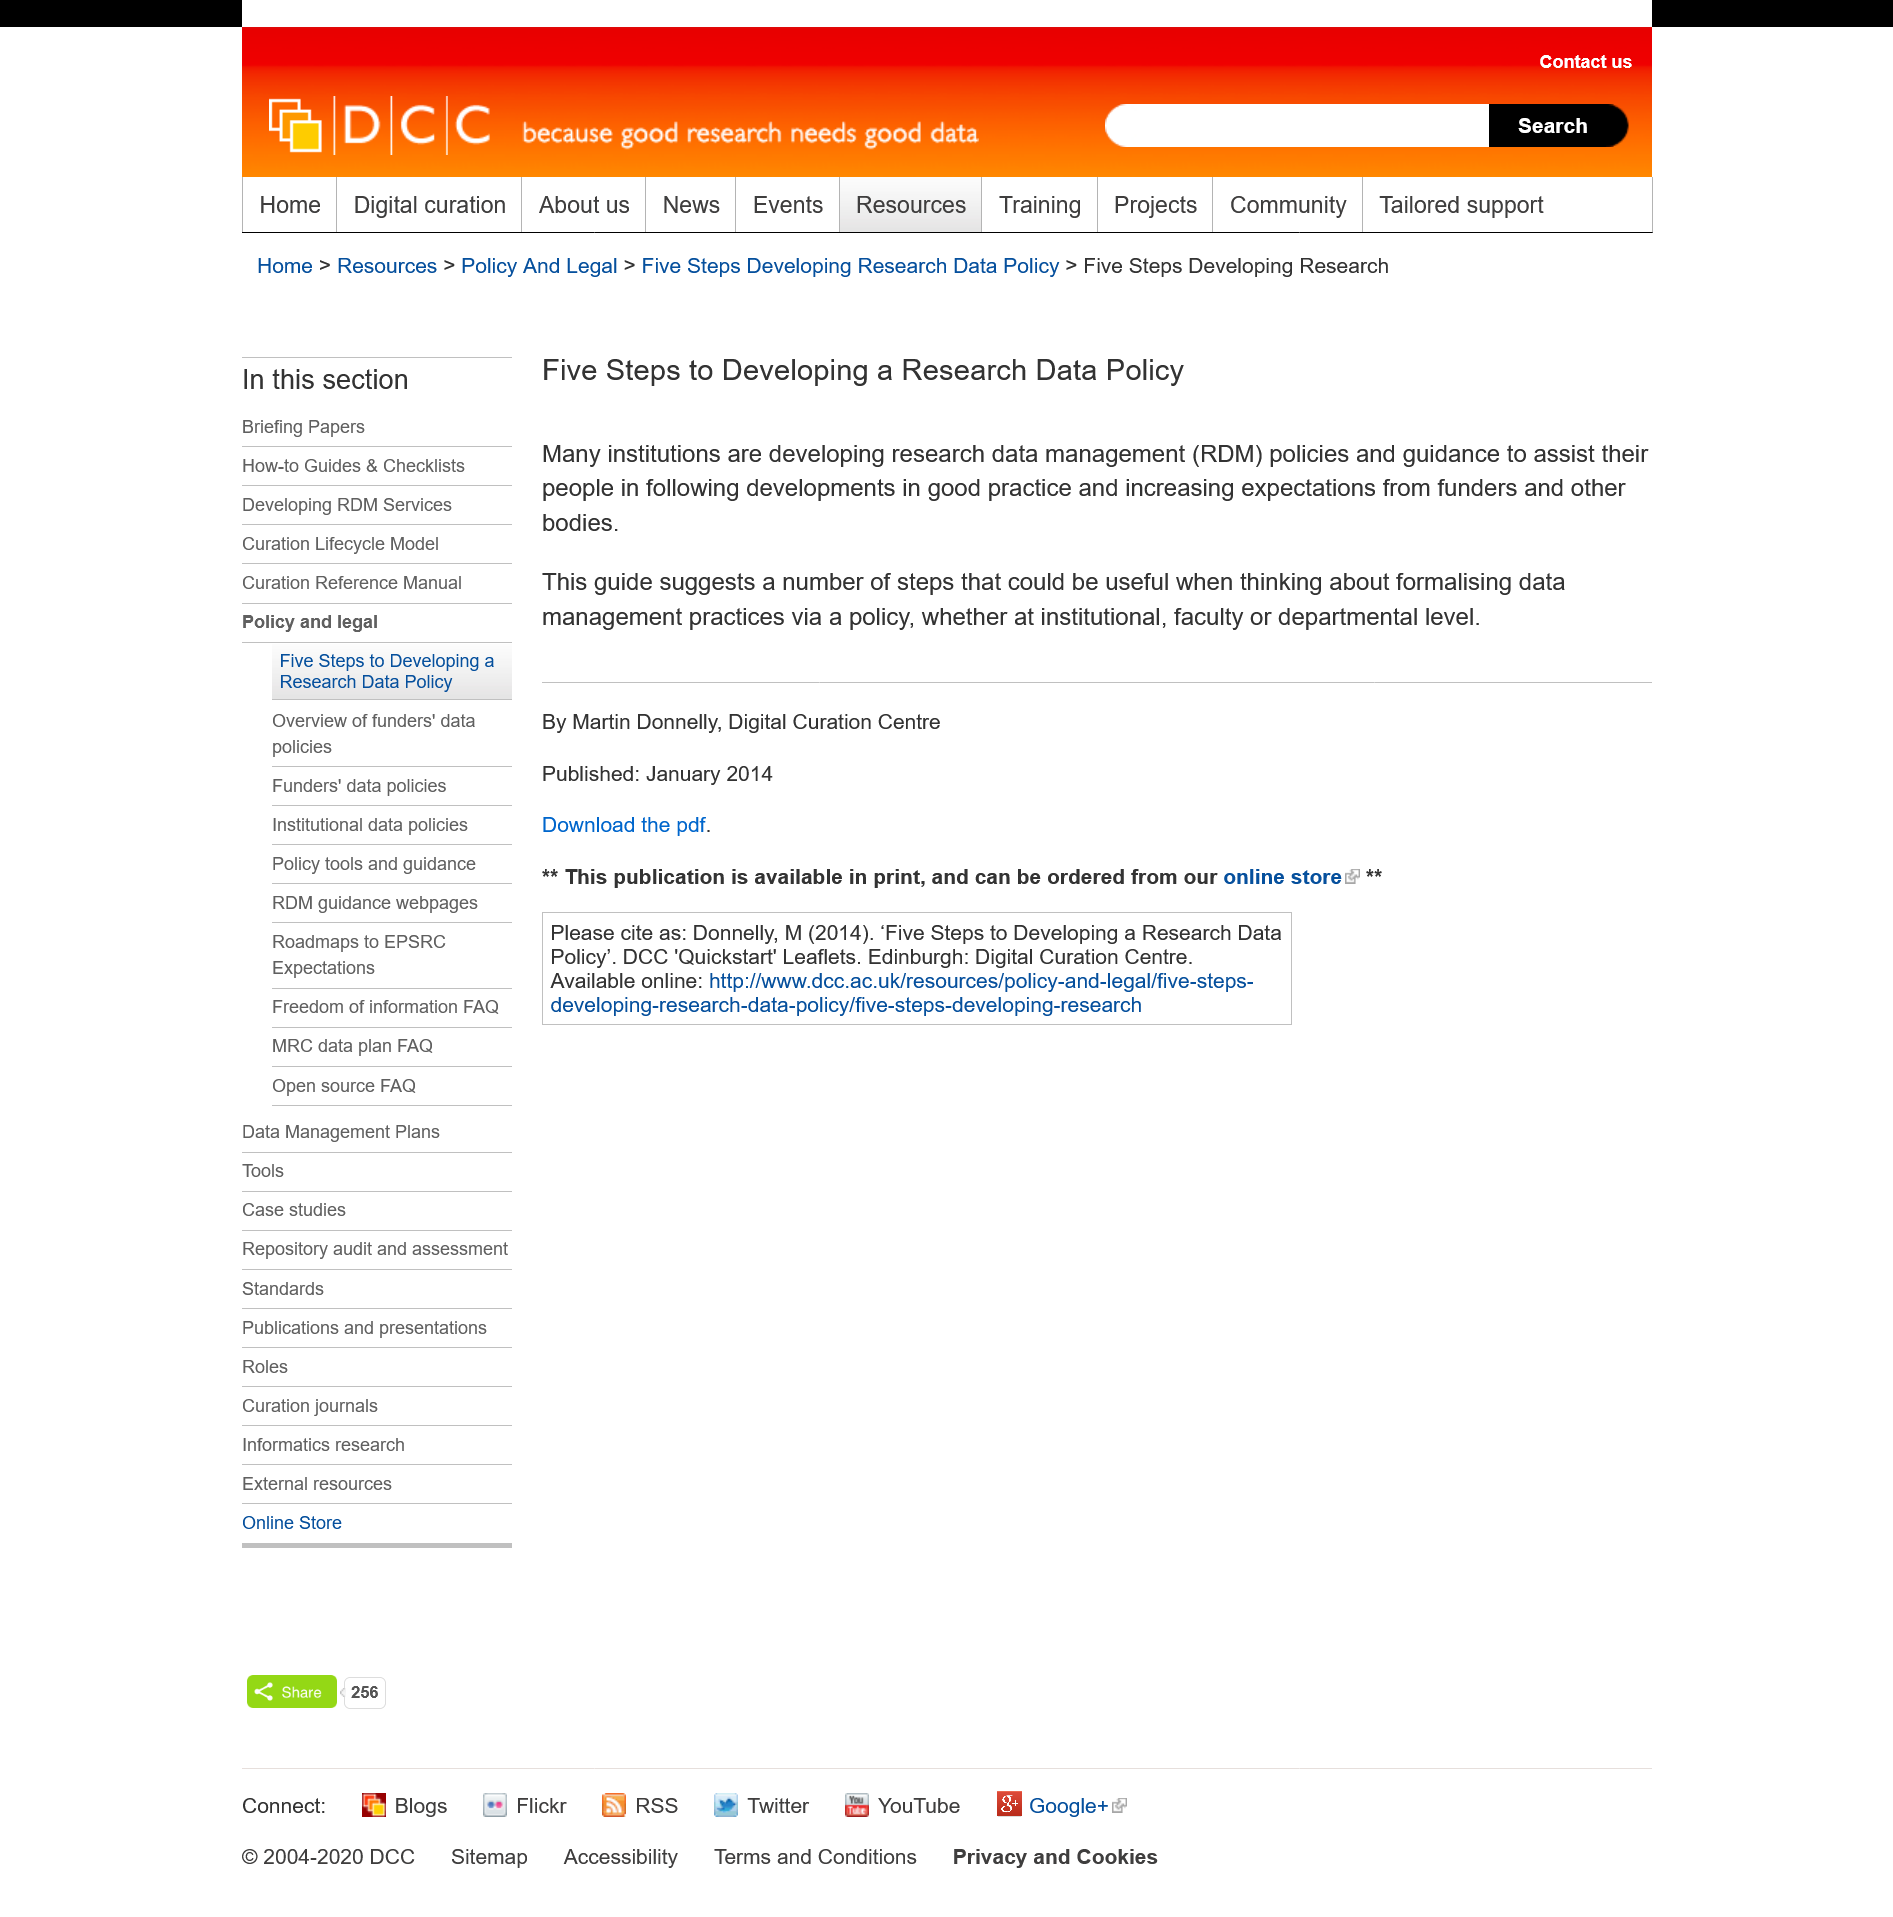Specify some key components in this picture. Developing a research data policy involves five steps, namely, identifying the need for a policy, defining the scope and goals, creating a plan, implementing and communicating the policy, and evaluating and updating the policy. The title of the page is "Five Steps to Developing a Research Data Policy. Research Data Management is a concept that refers to the processes and systems used to organize, store, and share research data in an efficient and effective manner. 